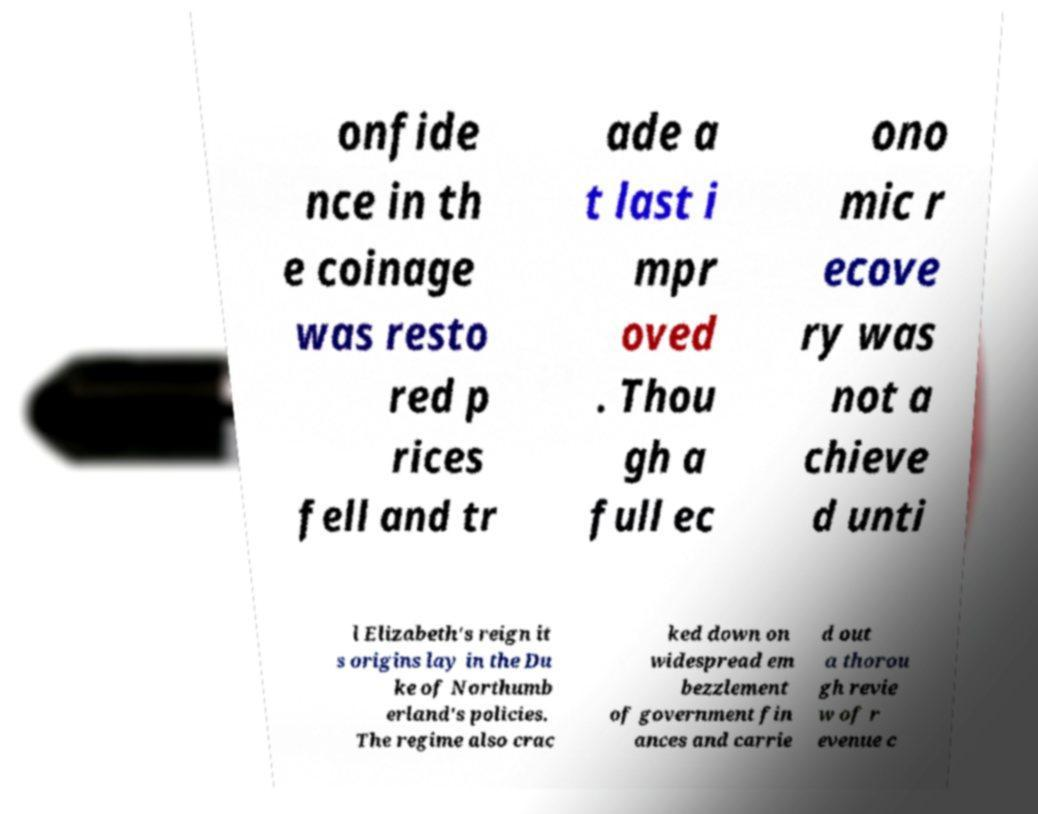Please identify and transcribe the text found in this image. onfide nce in th e coinage was resto red p rices fell and tr ade a t last i mpr oved . Thou gh a full ec ono mic r ecove ry was not a chieve d unti l Elizabeth's reign it s origins lay in the Du ke of Northumb erland's policies. The regime also crac ked down on widespread em bezzlement of government fin ances and carrie d out a thorou gh revie w of r evenue c 